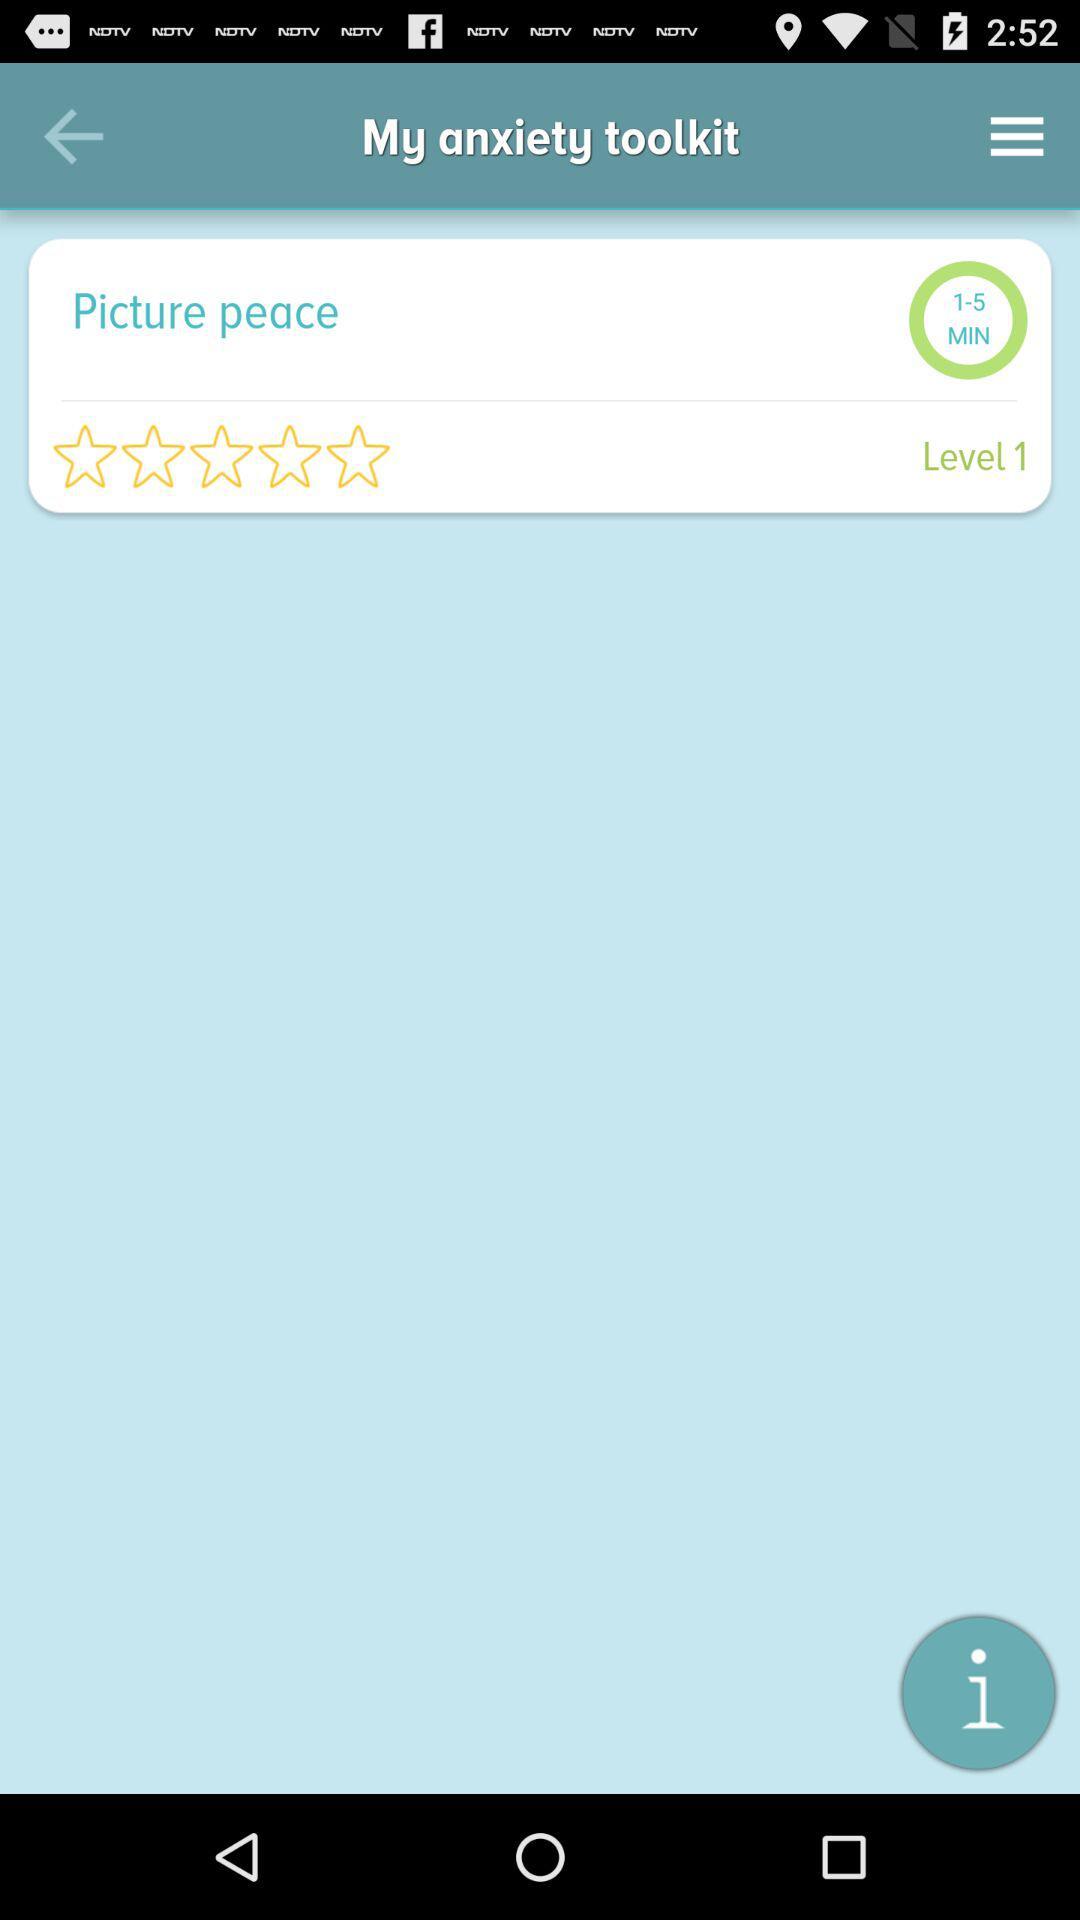What is the duration given on the screen? The duration given on the screen is 1 to 5 minutes. 